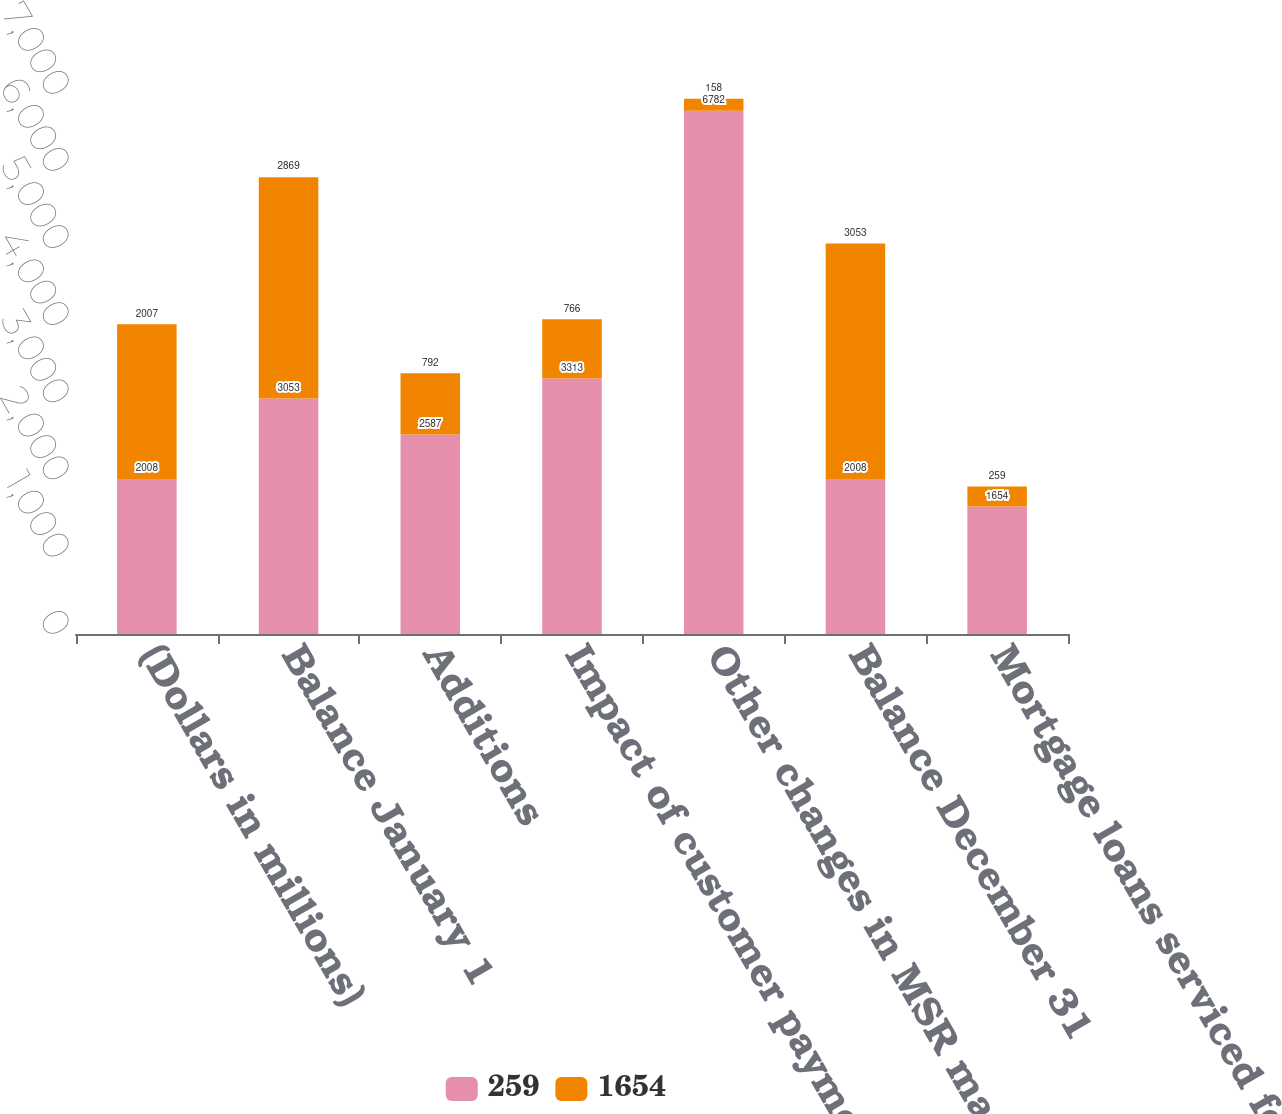<chart> <loc_0><loc_0><loc_500><loc_500><stacked_bar_chart><ecel><fcel>(Dollars in millions)<fcel>Balance January 1<fcel>Additions<fcel>Impact of customer payments<fcel>Other changes in MSR market<fcel>Balance December 31<fcel>Mortgage loans serviced for<nl><fcel>259<fcel>2008<fcel>3053<fcel>2587<fcel>3313<fcel>6782<fcel>2008<fcel>1654<nl><fcel>1654<fcel>2007<fcel>2869<fcel>792<fcel>766<fcel>158<fcel>3053<fcel>259<nl></chart> 